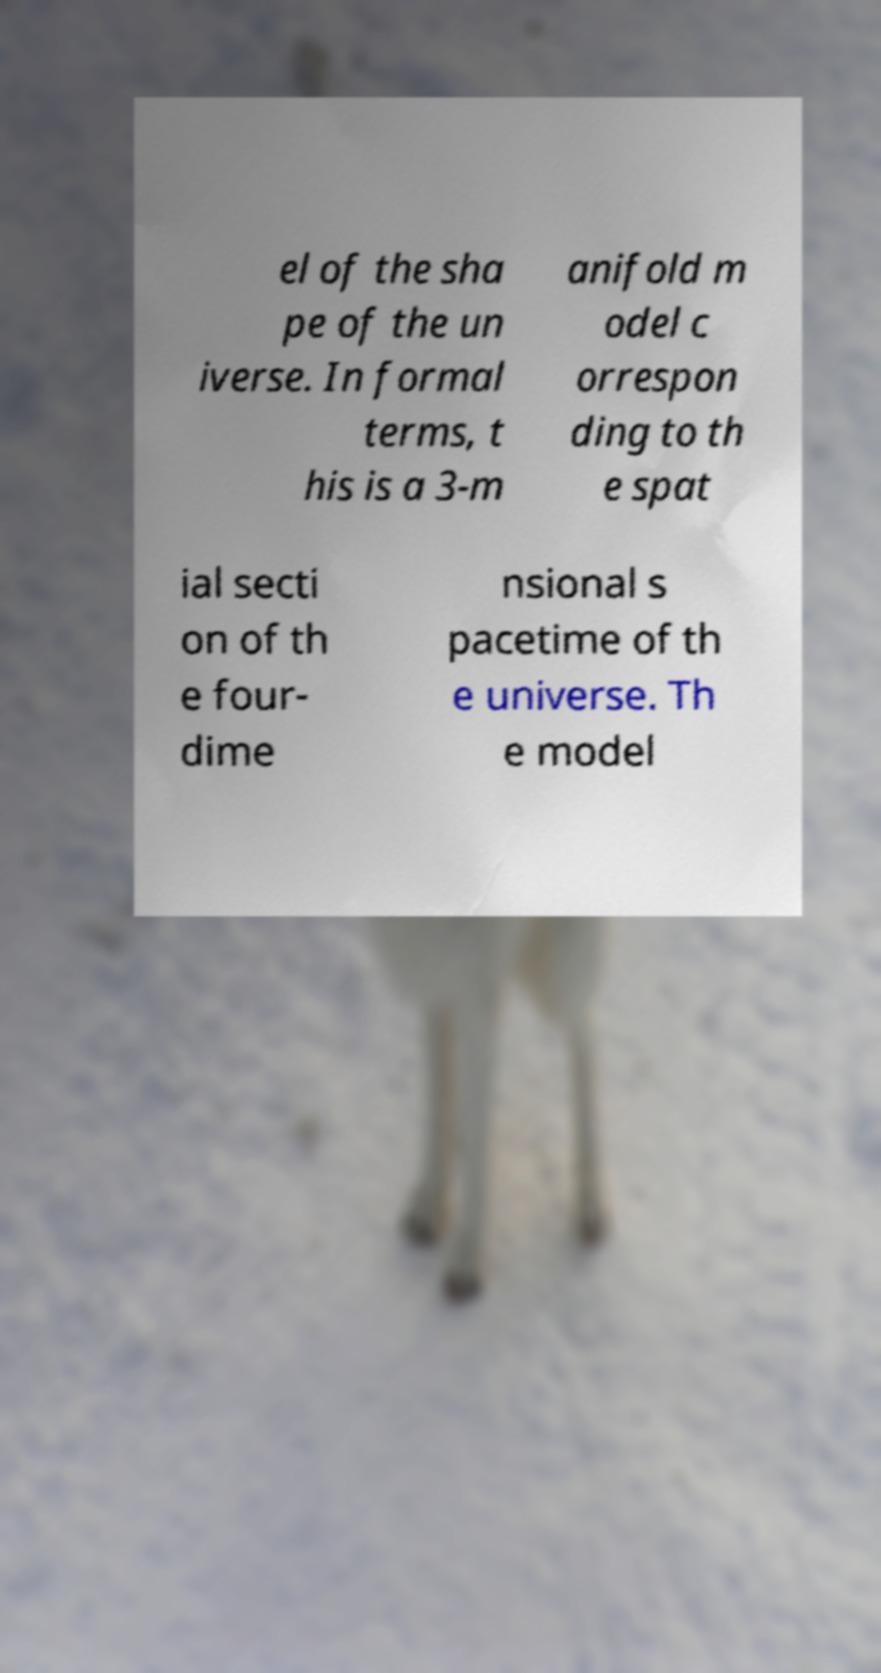There's text embedded in this image that I need extracted. Can you transcribe it verbatim? el of the sha pe of the un iverse. In formal terms, t his is a 3-m anifold m odel c orrespon ding to th e spat ial secti on of th e four- dime nsional s pacetime of th e universe. Th e model 